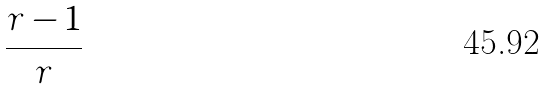<formula> <loc_0><loc_0><loc_500><loc_500>\frac { r - 1 } { r }</formula> 